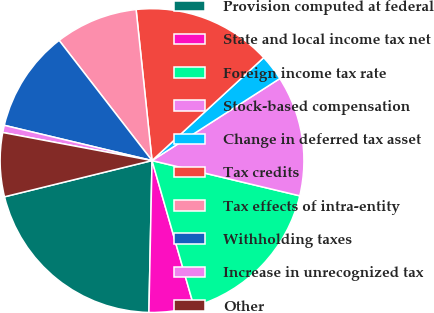Convert chart to OTSL. <chart><loc_0><loc_0><loc_500><loc_500><pie_chart><fcel>Provision computed at federal<fcel>State and local income tax net<fcel>Foreign income tax rate<fcel>Stock-based compensation<fcel>Change in deferred tax asset<fcel>Tax credits<fcel>Tax effects of intra-entity<fcel>Withholding taxes<fcel>Increase in unrecognized tax<fcel>Other<nl><fcel>20.84%<fcel>4.78%<fcel>16.82%<fcel>12.81%<fcel>2.77%<fcel>14.82%<fcel>8.8%<fcel>10.8%<fcel>0.77%<fcel>6.79%<nl></chart> 